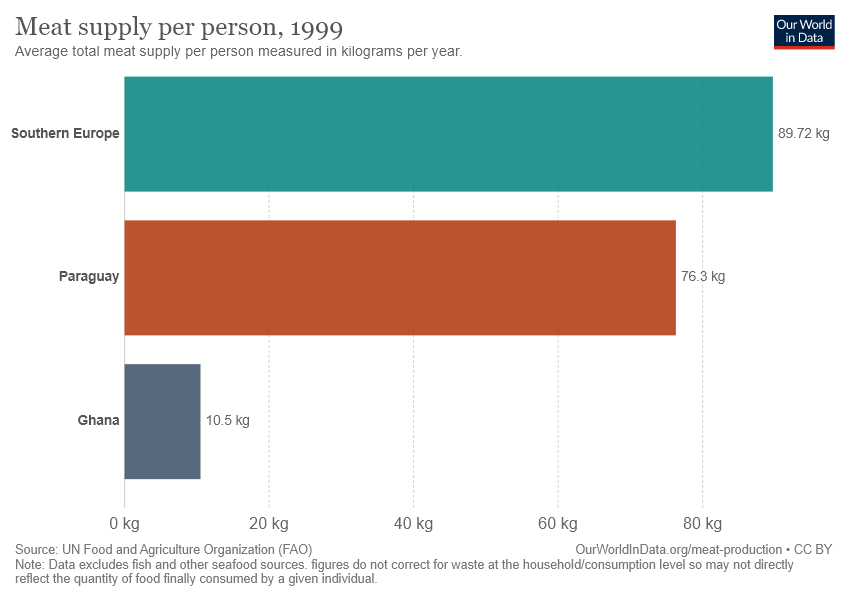Can you infer the time period of the data represented in the image? The image indicates that the data corresponds to meat supply per person in the year 1999. This is demonstrated by the title of the chart and should be considered when making historical or current comparisons, as dietary patterns and supply chains could have evolved since then. 